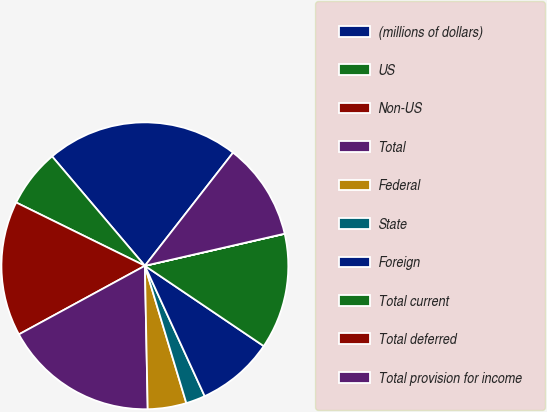<chart> <loc_0><loc_0><loc_500><loc_500><pie_chart><fcel>(millions of dollars)<fcel>US<fcel>Non-US<fcel>Total<fcel>Federal<fcel>State<fcel>Foreign<fcel>Total current<fcel>Total deferred<fcel>Total provision for income<nl><fcel>21.73%<fcel>6.53%<fcel>15.21%<fcel>17.38%<fcel>4.35%<fcel>2.18%<fcel>8.7%<fcel>13.04%<fcel>0.01%<fcel>10.87%<nl></chart> 